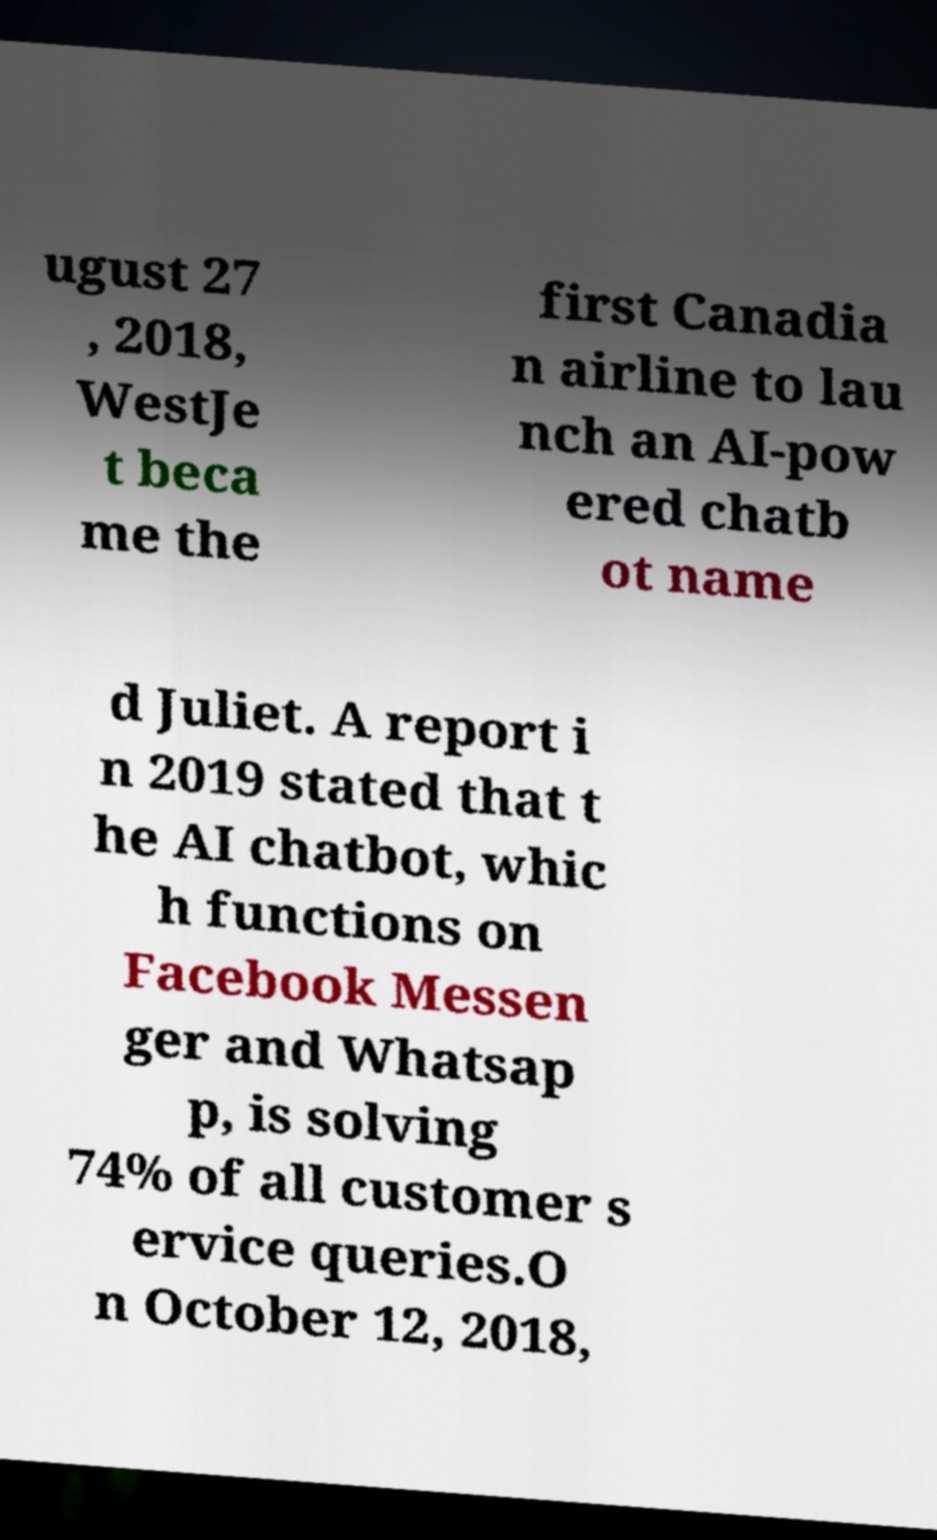Could you extract and type out the text from this image? ugust 27 , 2018, WestJe t beca me the first Canadia n airline to lau nch an AI-pow ered chatb ot name d Juliet. A report i n 2019 stated that t he AI chatbot, whic h functions on Facebook Messen ger and Whatsap p, is solving 74% of all customer s ervice queries.O n October 12, 2018, 